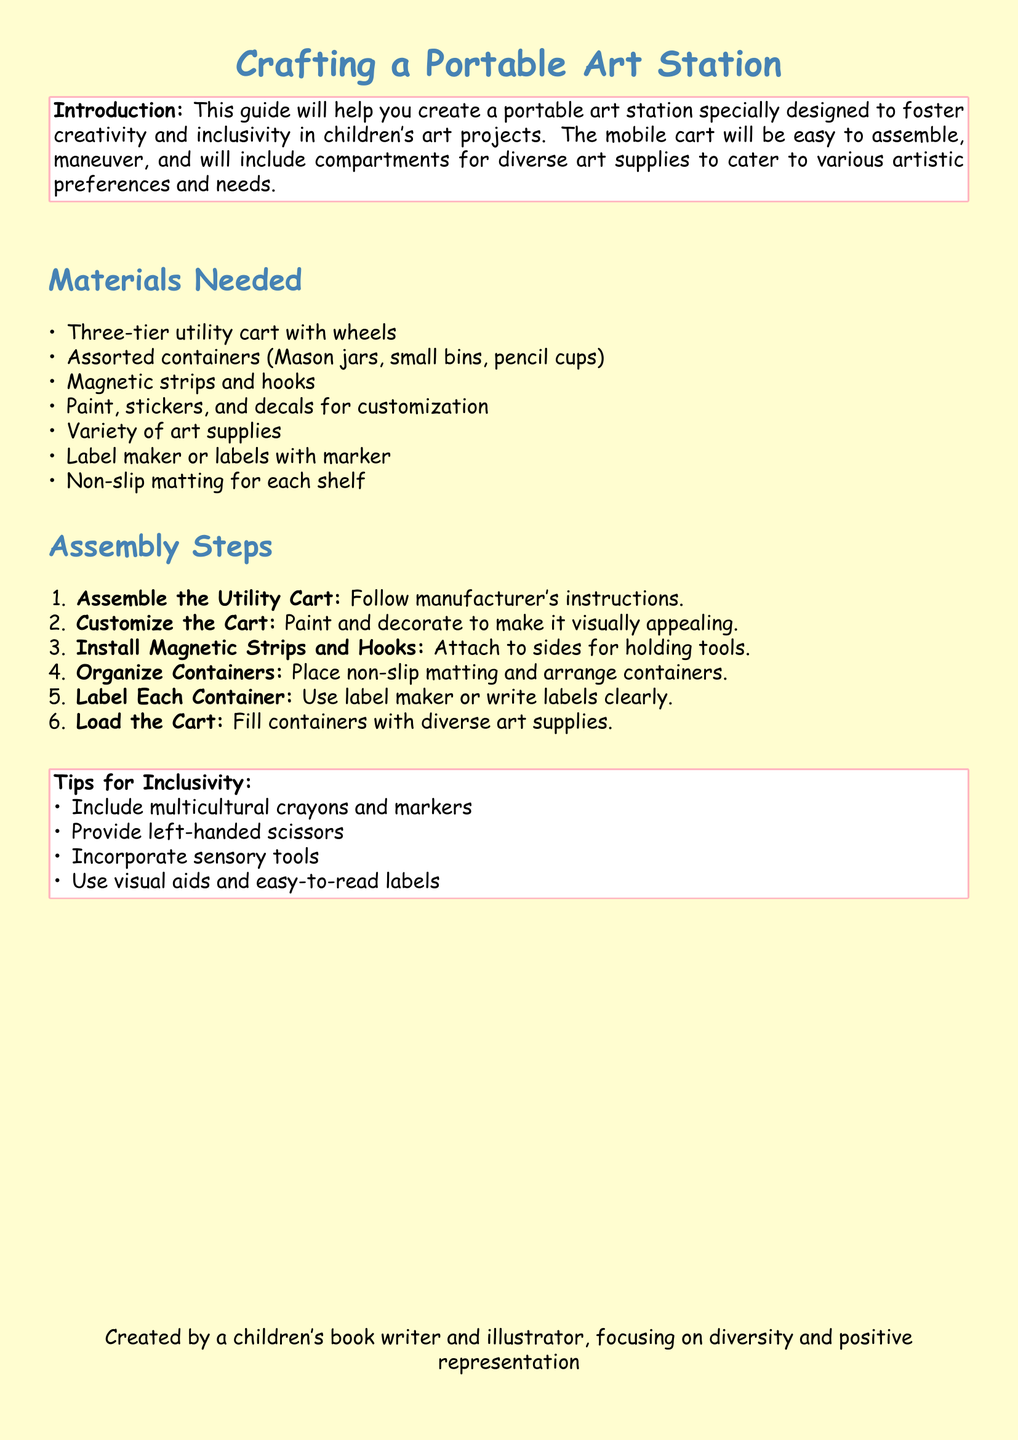What is the title of the document? The title is the main heading that introduces the content of the document, which is "Crafting a Portable Art Station."
Answer: Crafting a Portable Art Station How many tiers does the utility cart have? The utility cart mentioned in the materials needed section is specified to have three tiers.
Answer: Three What type of scissors is suggested for inclusivity? The document mentions providing a specific type of scissors that caters to a group of users, which are left-handed scissors.
Answer: Left-handed scissors What is used to attach tools to the sides of the cart? Magnetic strips and hooks are the materials specified for holding tools on the sides of the cart.
Answer: Magnetic strips and hooks What should be used for organizing the containers on the cart? The document specifies using a certain type of matting to prevent sliding, identified as non-slip matting.
Answer: Non-slip matting What is included in the tips for inclusivity? One of the inclusivity tips involves providing specific types of crayons, indicated as multicultural crayons and markers.
Answer: Multicultural crayons and markers During which step do you fill the containers with art supplies? The final assembly step is explicitly described as the one where you fill the containers with art supplies, which is the sixth step.
Answer: Sixth What should you use to label each container? The document suggests using a labeling tool or method that is easy to read, specified as a label maker or labels with a marker.
Answer: Label maker or labels with marker 